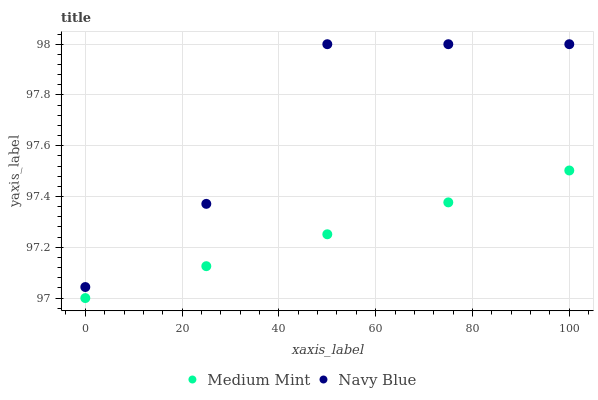Does Medium Mint have the minimum area under the curve?
Answer yes or no. Yes. Does Navy Blue have the maximum area under the curve?
Answer yes or no. Yes. Does Navy Blue have the minimum area under the curve?
Answer yes or no. No. Is Medium Mint the smoothest?
Answer yes or no. Yes. Is Navy Blue the roughest?
Answer yes or no. Yes. Is Navy Blue the smoothest?
Answer yes or no. No. Does Medium Mint have the lowest value?
Answer yes or no. Yes. Does Navy Blue have the lowest value?
Answer yes or no. No. Does Navy Blue have the highest value?
Answer yes or no. Yes. Is Medium Mint less than Navy Blue?
Answer yes or no. Yes. Is Navy Blue greater than Medium Mint?
Answer yes or no. Yes. Does Medium Mint intersect Navy Blue?
Answer yes or no. No. 